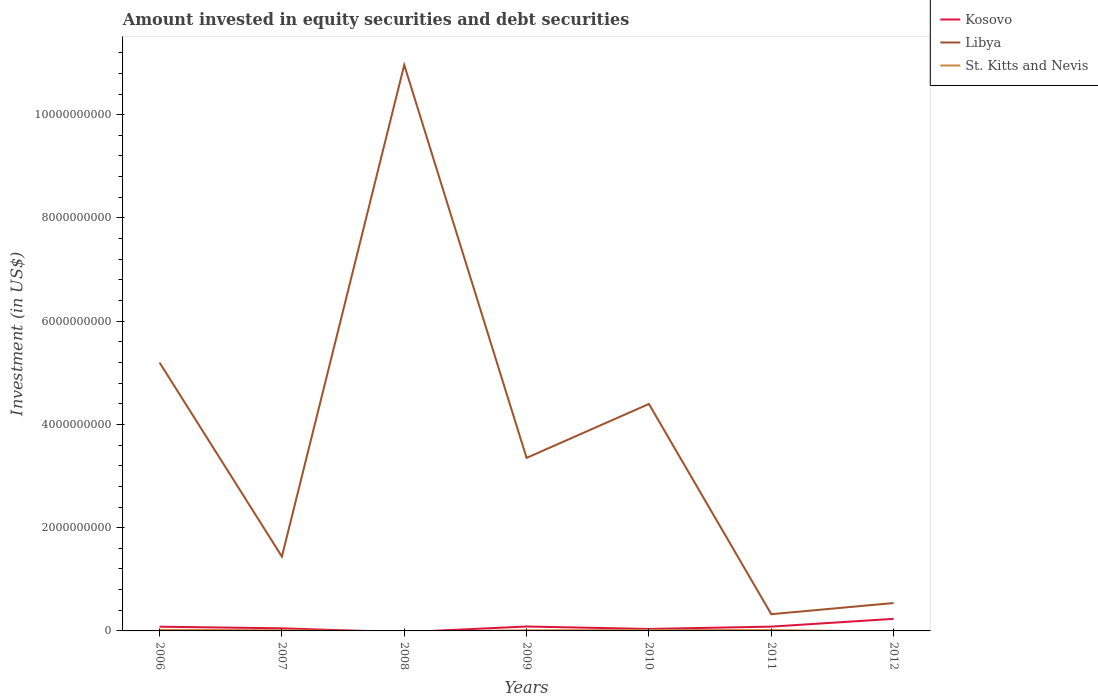How many different coloured lines are there?
Make the answer very short. 3. Is the number of lines equal to the number of legend labels?
Offer a very short reply. No. What is the total amount invested in equity securities and debt securities in Kosovo in the graph?
Keep it short and to the point. -1.15e+06. What is the difference between the highest and the second highest amount invested in equity securities and debt securities in Kosovo?
Offer a very short reply. 2.34e+08. What is the difference between the highest and the lowest amount invested in equity securities and debt securities in St. Kitts and Nevis?
Ensure brevity in your answer.  5. What is the difference between two consecutive major ticks on the Y-axis?
Offer a very short reply. 2.00e+09. Does the graph contain any zero values?
Give a very brief answer. Yes. How many legend labels are there?
Provide a short and direct response. 3. What is the title of the graph?
Make the answer very short. Amount invested in equity securities and debt securities. Does "Vietnam" appear as one of the legend labels in the graph?
Your answer should be very brief. No. What is the label or title of the Y-axis?
Offer a very short reply. Investment (in US$). What is the Investment (in US$) in Kosovo in 2006?
Make the answer very short. 8.20e+07. What is the Investment (in US$) in Libya in 2006?
Make the answer very short. 5.20e+09. What is the Investment (in US$) of St. Kitts and Nevis in 2006?
Give a very brief answer. 2.10e+07. What is the Investment (in US$) of Kosovo in 2007?
Your response must be concise. 5.01e+07. What is the Investment (in US$) in Libya in 2007?
Your answer should be very brief. 1.44e+09. What is the Investment (in US$) of St. Kitts and Nevis in 2007?
Make the answer very short. 1.30e+07. What is the Investment (in US$) of Kosovo in 2008?
Ensure brevity in your answer.  0. What is the Investment (in US$) in Libya in 2008?
Your answer should be compact. 1.10e+1. What is the Investment (in US$) in Kosovo in 2009?
Provide a succinct answer. 8.56e+07. What is the Investment (in US$) of Libya in 2009?
Your answer should be compact. 3.35e+09. What is the Investment (in US$) in St. Kitts and Nevis in 2009?
Ensure brevity in your answer.  1.12e+07. What is the Investment (in US$) of Kosovo in 2010?
Keep it short and to the point. 3.79e+07. What is the Investment (in US$) in Libya in 2010?
Make the answer very short. 4.40e+09. What is the Investment (in US$) in St. Kitts and Nevis in 2010?
Keep it short and to the point. 1.72e+07. What is the Investment (in US$) in Kosovo in 2011?
Your response must be concise. 8.32e+07. What is the Investment (in US$) in Libya in 2011?
Your response must be concise. 3.24e+08. What is the Investment (in US$) in St. Kitts and Nevis in 2011?
Keep it short and to the point. 1.55e+07. What is the Investment (in US$) in Kosovo in 2012?
Your response must be concise. 2.34e+08. What is the Investment (in US$) of Libya in 2012?
Make the answer very short. 5.40e+08. What is the Investment (in US$) in St. Kitts and Nevis in 2012?
Your answer should be very brief. 0. Across all years, what is the maximum Investment (in US$) of Kosovo?
Make the answer very short. 2.34e+08. Across all years, what is the maximum Investment (in US$) in Libya?
Your response must be concise. 1.10e+1. Across all years, what is the maximum Investment (in US$) of St. Kitts and Nevis?
Your response must be concise. 2.10e+07. Across all years, what is the minimum Investment (in US$) in Libya?
Ensure brevity in your answer.  3.24e+08. What is the total Investment (in US$) of Kosovo in the graph?
Provide a short and direct response. 5.73e+08. What is the total Investment (in US$) in Libya in the graph?
Offer a terse response. 2.62e+1. What is the total Investment (in US$) in St. Kitts and Nevis in the graph?
Give a very brief answer. 7.78e+07. What is the difference between the Investment (in US$) of Kosovo in 2006 and that in 2007?
Provide a short and direct response. 3.19e+07. What is the difference between the Investment (in US$) in Libya in 2006 and that in 2007?
Offer a very short reply. 3.76e+09. What is the difference between the Investment (in US$) of St. Kitts and Nevis in 2006 and that in 2007?
Make the answer very short. 7.99e+06. What is the difference between the Investment (in US$) in Libya in 2006 and that in 2008?
Make the answer very short. -5.77e+09. What is the difference between the Investment (in US$) in Kosovo in 2006 and that in 2009?
Your answer should be very brief. -3.60e+06. What is the difference between the Investment (in US$) of Libya in 2006 and that in 2009?
Your response must be concise. 1.85e+09. What is the difference between the Investment (in US$) of St. Kitts and Nevis in 2006 and that in 2009?
Give a very brief answer. 9.81e+06. What is the difference between the Investment (in US$) in Kosovo in 2006 and that in 2010?
Make the answer very short. 4.41e+07. What is the difference between the Investment (in US$) of Libya in 2006 and that in 2010?
Provide a succinct answer. 8.02e+08. What is the difference between the Investment (in US$) of St. Kitts and Nevis in 2006 and that in 2010?
Keep it short and to the point. 3.73e+06. What is the difference between the Investment (in US$) in Kosovo in 2006 and that in 2011?
Your answer should be compact. -1.15e+06. What is the difference between the Investment (in US$) of Libya in 2006 and that in 2011?
Make the answer very short. 4.87e+09. What is the difference between the Investment (in US$) of St. Kitts and Nevis in 2006 and that in 2011?
Provide a succinct answer. 5.51e+06. What is the difference between the Investment (in US$) in Kosovo in 2006 and that in 2012?
Your answer should be compact. -1.52e+08. What is the difference between the Investment (in US$) of Libya in 2006 and that in 2012?
Ensure brevity in your answer.  4.66e+09. What is the difference between the Investment (in US$) of Libya in 2007 and that in 2008?
Provide a succinct answer. -9.52e+09. What is the difference between the Investment (in US$) in Kosovo in 2007 and that in 2009?
Give a very brief answer. -3.55e+07. What is the difference between the Investment (in US$) of Libya in 2007 and that in 2009?
Provide a succinct answer. -1.91e+09. What is the difference between the Investment (in US$) of St. Kitts and Nevis in 2007 and that in 2009?
Offer a terse response. 1.82e+06. What is the difference between the Investment (in US$) of Kosovo in 2007 and that in 2010?
Your answer should be very brief. 1.22e+07. What is the difference between the Investment (in US$) of Libya in 2007 and that in 2010?
Keep it short and to the point. -2.96e+09. What is the difference between the Investment (in US$) in St. Kitts and Nevis in 2007 and that in 2010?
Provide a short and direct response. -4.27e+06. What is the difference between the Investment (in US$) of Kosovo in 2007 and that in 2011?
Provide a succinct answer. -3.31e+07. What is the difference between the Investment (in US$) in Libya in 2007 and that in 2011?
Keep it short and to the point. 1.12e+09. What is the difference between the Investment (in US$) in St. Kitts and Nevis in 2007 and that in 2011?
Provide a succinct answer. -2.48e+06. What is the difference between the Investment (in US$) in Kosovo in 2007 and that in 2012?
Give a very brief answer. -1.84e+08. What is the difference between the Investment (in US$) of Libya in 2007 and that in 2012?
Your response must be concise. 9.00e+08. What is the difference between the Investment (in US$) of Libya in 2008 and that in 2009?
Your answer should be compact. 7.61e+09. What is the difference between the Investment (in US$) of Libya in 2008 and that in 2010?
Ensure brevity in your answer.  6.57e+09. What is the difference between the Investment (in US$) in Libya in 2008 and that in 2011?
Your answer should be very brief. 1.06e+1. What is the difference between the Investment (in US$) of Libya in 2008 and that in 2012?
Offer a terse response. 1.04e+1. What is the difference between the Investment (in US$) in Kosovo in 2009 and that in 2010?
Offer a terse response. 4.77e+07. What is the difference between the Investment (in US$) in Libya in 2009 and that in 2010?
Provide a succinct answer. -1.04e+09. What is the difference between the Investment (in US$) of St. Kitts and Nevis in 2009 and that in 2010?
Your response must be concise. -6.08e+06. What is the difference between the Investment (in US$) in Kosovo in 2009 and that in 2011?
Your answer should be compact. 2.44e+06. What is the difference between the Investment (in US$) in Libya in 2009 and that in 2011?
Your answer should be very brief. 3.03e+09. What is the difference between the Investment (in US$) in St. Kitts and Nevis in 2009 and that in 2011?
Provide a short and direct response. -4.30e+06. What is the difference between the Investment (in US$) in Kosovo in 2009 and that in 2012?
Offer a terse response. -1.48e+08. What is the difference between the Investment (in US$) in Libya in 2009 and that in 2012?
Keep it short and to the point. 2.81e+09. What is the difference between the Investment (in US$) in Kosovo in 2010 and that in 2011?
Keep it short and to the point. -4.53e+07. What is the difference between the Investment (in US$) of Libya in 2010 and that in 2011?
Provide a succinct answer. 4.07e+09. What is the difference between the Investment (in US$) of St. Kitts and Nevis in 2010 and that in 2011?
Offer a terse response. 1.78e+06. What is the difference between the Investment (in US$) of Kosovo in 2010 and that in 2012?
Make the answer very short. -1.96e+08. What is the difference between the Investment (in US$) of Libya in 2010 and that in 2012?
Your answer should be compact. 3.86e+09. What is the difference between the Investment (in US$) of Kosovo in 2011 and that in 2012?
Your answer should be compact. -1.51e+08. What is the difference between the Investment (in US$) of Libya in 2011 and that in 2012?
Offer a terse response. -2.16e+08. What is the difference between the Investment (in US$) of Kosovo in 2006 and the Investment (in US$) of Libya in 2007?
Offer a terse response. -1.36e+09. What is the difference between the Investment (in US$) of Kosovo in 2006 and the Investment (in US$) of St. Kitts and Nevis in 2007?
Ensure brevity in your answer.  6.91e+07. What is the difference between the Investment (in US$) of Libya in 2006 and the Investment (in US$) of St. Kitts and Nevis in 2007?
Offer a very short reply. 5.19e+09. What is the difference between the Investment (in US$) in Kosovo in 2006 and the Investment (in US$) in Libya in 2008?
Offer a terse response. -1.09e+1. What is the difference between the Investment (in US$) of Kosovo in 2006 and the Investment (in US$) of Libya in 2009?
Your response must be concise. -3.27e+09. What is the difference between the Investment (in US$) of Kosovo in 2006 and the Investment (in US$) of St. Kitts and Nevis in 2009?
Ensure brevity in your answer.  7.09e+07. What is the difference between the Investment (in US$) of Libya in 2006 and the Investment (in US$) of St. Kitts and Nevis in 2009?
Your answer should be compact. 5.19e+09. What is the difference between the Investment (in US$) in Kosovo in 2006 and the Investment (in US$) in Libya in 2010?
Provide a succinct answer. -4.31e+09. What is the difference between the Investment (in US$) in Kosovo in 2006 and the Investment (in US$) in St. Kitts and Nevis in 2010?
Provide a succinct answer. 6.48e+07. What is the difference between the Investment (in US$) in Libya in 2006 and the Investment (in US$) in St. Kitts and Nevis in 2010?
Provide a short and direct response. 5.18e+09. What is the difference between the Investment (in US$) of Kosovo in 2006 and the Investment (in US$) of Libya in 2011?
Your answer should be compact. -2.42e+08. What is the difference between the Investment (in US$) of Kosovo in 2006 and the Investment (in US$) of St. Kitts and Nevis in 2011?
Keep it short and to the point. 6.66e+07. What is the difference between the Investment (in US$) of Libya in 2006 and the Investment (in US$) of St. Kitts and Nevis in 2011?
Ensure brevity in your answer.  5.18e+09. What is the difference between the Investment (in US$) in Kosovo in 2006 and the Investment (in US$) in Libya in 2012?
Offer a terse response. -4.58e+08. What is the difference between the Investment (in US$) of Kosovo in 2007 and the Investment (in US$) of Libya in 2008?
Your response must be concise. -1.09e+1. What is the difference between the Investment (in US$) in Kosovo in 2007 and the Investment (in US$) in Libya in 2009?
Your response must be concise. -3.30e+09. What is the difference between the Investment (in US$) in Kosovo in 2007 and the Investment (in US$) in St. Kitts and Nevis in 2009?
Keep it short and to the point. 3.89e+07. What is the difference between the Investment (in US$) in Libya in 2007 and the Investment (in US$) in St. Kitts and Nevis in 2009?
Offer a terse response. 1.43e+09. What is the difference between the Investment (in US$) in Kosovo in 2007 and the Investment (in US$) in Libya in 2010?
Provide a short and direct response. -4.35e+09. What is the difference between the Investment (in US$) in Kosovo in 2007 and the Investment (in US$) in St. Kitts and Nevis in 2010?
Offer a terse response. 3.29e+07. What is the difference between the Investment (in US$) in Libya in 2007 and the Investment (in US$) in St. Kitts and Nevis in 2010?
Provide a succinct answer. 1.42e+09. What is the difference between the Investment (in US$) of Kosovo in 2007 and the Investment (in US$) of Libya in 2011?
Your answer should be very brief. -2.74e+08. What is the difference between the Investment (in US$) of Kosovo in 2007 and the Investment (in US$) of St. Kitts and Nevis in 2011?
Your answer should be very brief. 3.46e+07. What is the difference between the Investment (in US$) of Libya in 2007 and the Investment (in US$) of St. Kitts and Nevis in 2011?
Provide a short and direct response. 1.42e+09. What is the difference between the Investment (in US$) in Kosovo in 2007 and the Investment (in US$) in Libya in 2012?
Keep it short and to the point. -4.90e+08. What is the difference between the Investment (in US$) in Libya in 2008 and the Investment (in US$) in St. Kitts and Nevis in 2009?
Offer a very short reply. 1.10e+1. What is the difference between the Investment (in US$) in Libya in 2008 and the Investment (in US$) in St. Kitts and Nevis in 2010?
Provide a succinct answer. 1.09e+1. What is the difference between the Investment (in US$) of Libya in 2008 and the Investment (in US$) of St. Kitts and Nevis in 2011?
Keep it short and to the point. 1.09e+1. What is the difference between the Investment (in US$) of Kosovo in 2009 and the Investment (in US$) of Libya in 2010?
Offer a terse response. -4.31e+09. What is the difference between the Investment (in US$) in Kosovo in 2009 and the Investment (in US$) in St. Kitts and Nevis in 2010?
Keep it short and to the point. 6.84e+07. What is the difference between the Investment (in US$) of Libya in 2009 and the Investment (in US$) of St. Kitts and Nevis in 2010?
Offer a terse response. 3.33e+09. What is the difference between the Investment (in US$) in Kosovo in 2009 and the Investment (in US$) in Libya in 2011?
Your response must be concise. -2.38e+08. What is the difference between the Investment (in US$) in Kosovo in 2009 and the Investment (in US$) in St. Kitts and Nevis in 2011?
Provide a succinct answer. 7.02e+07. What is the difference between the Investment (in US$) of Libya in 2009 and the Investment (in US$) of St. Kitts and Nevis in 2011?
Your response must be concise. 3.34e+09. What is the difference between the Investment (in US$) of Kosovo in 2009 and the Investment (in US$) of Libya in 2012?
Your answer should be very brief. -4.55e+08. What is the difference between the Investment (in US$) in Kosovo in 2010 and the Investment (in US$) in Libya in 2011?
Provide a succinct answer. -2.86e+08. What is the difference between the Investment (in US$) in Kosovo in 2010 and the Investment (in US$) in St. Kitts and Nevis in 2011?
Give a very brief answer. 2.24e+07. What is the difference between the Investment (in US$) of Libya in 2010 and the Investment (in US$) of St. Kitts and Nevis in 2011?
Your response must be concise. 4.38e+09. What is the difference between the Investment (in US$) in Kosovo in 2010 and the Investment (in US$) in Libya in 2012?
Provide a succinct answer. -5.02e+08. What is the difference between the Investment (in US$) in Kosovo in 2011 and the Investment (in US$) in Libya in 2012?
Your answer should be very brief. -4.57e+08. What is the average Investment (in US$) of Kosovo per year?
Your answer should be compact. 8.18e+07. What is the average Investment (in US$) of Libya per year?
Make the answer very short. 3.74e+09. What is the average Investment (in US$) in St. Kitts and Nevis per year?
Your response must be concise. 1.11e+07. In the year 2006, what is the difference between the Investment (in US$) in Kosovo and Investment (in US$) in Libya?
Provide a succinct answer. -5.12e+09. In the year 2006, what is the difference between the Investment (in US$) of Kosovo and Investment (in US$) of St. Kitts and Nevis?
Offer a terse response. 6.11e+07. In the year 2006, what is the difference between the Investment (in US$) in Libya and Investment (in US$) in St. Kitts and Nevis?
Keep it short and to the point. 5.18e+09. In the year 2007, what is the difference between the Investment (in US$) of Kosovo and Investment (in US$) of Libya?
Provide a succinct answer. -1.39e+09. In the year 2007, what is the difference between the Investment (in US$) of Kosovo and Investment (in US$) of St. Kitts and Nevis?
Offer a very short reply. 3.71e+07. In the year 2007, what is the difference between the Investment (in US$) in Libya and Investment (in US$) in St. Kitts and Nevis?
Ensure brevity in your answer.  1.43e+09. In the year 2009, what is the difference between the Investment (in US$) in Kosovo and Investment (in US$) in Libya?
Offer a terse response. -3.27e+09. In the year 2009, what is the difference between the Investment (in US$) of Kosovo and Investment (in US$) of St. Kitts and Nevis?
Ensure brevity in your answer.  7.45e+07. In the year 2009, what is the difference between the Investment (in US$) in Libya and Investment (in US$) in St. Kitts and Nevis?
Your response must be concise. 3.34e+09. In the year 2010, what is the difference between the Investment (in US$) of Kosovo and Investment (in US$) of Libya?
Provide a succinct answer. -4.36e+09. In the year 2010, what is the difference between the Investment (in US$) in Kosovo and Investment (in US$) in St. Kitts and Nevis?
Your answer should be compact. 2.07e+07. In the year 2010, what is the difference between the Investment (in US$) of Libya and Investment (in US$) of St. Kitts and Nevis?
Offer a very short reply. 4.38e+09. In the year 2011, what is the difference between the Investment (in US$) in Kosovo and Investment (in US$) in Libya?
Give a very brief answer. -2.41e+08. In the year 2011, what is the difference between the Investment (in US$) in Kosovo and Investment (in US$) in St. Kitts and Nevis?
Your answer should be compact. 6.77e+07. In the year 2011, what is the difference between the Investment (in US$) of Libya and Investment (in US$) of St. Kitts and Nevis?
Provide a succinct answer. 3.09e+08. In the year 2012, what is the difference between the Investment (in US$) in Kosovo and Investment (in US$) in Libya?
Your answer should be very brief. -3.06e+08. What is the ratio of the Investment (in US$) in Kosovo in 2006 to that in 2007?
Make the answer very short. 1.64. What is the ratio of the Investment (in US$) of Libya in 2006 to that in 2007?
Offer a terse response. 3.61. What is the ratio of the Investment (in US$) in St. Kitts and Nevis in 2006 to that in 2007?
Your response must be concise. 1.62. What is the ratio of the Investment (in US$) of Libya in 2006 to that in 2008?
Your response must be concise. 0.47. What is the ratio of the Investment (in US$) of Kosovo in 2006 to that in 2009?
Give a very brief answer. 0.96. What is the ratio of the Investment (in US$) in Libya in 2006 to that in 2009?
Keep it short and to the point. 1.55. What is the ratio of the Investment (in US$) of St. Kitts and Nevis in 2006 to that in 2009?
Give a very brief answer. 1.88. What is the ratio of the Investment (in US$) in Kosovo in 2006 to that in 2010?
Your response must be concise. 2.16. What is the ratio of the Investment (in US$) of Libya in 2006 to that in 2010?
Provide a succinct answer. 1.18. What is the ratio of the Investment (in US$) in St. Kitts and Nevis in 2006 to that in 2010?
Your answer should be very brief. 1.22. What is the ratio of the Investment (in US$) in Kosovo in 2006 to that in 2011?
Your answer should be very brief. 0.99. What is the ratio of the Investment (in US$) of Libya in 2006 to that in 2011?
Give a very brief answer. 16.04. What is the ratio of the Investment (in US$) of St. Kitts and Nevis in 2006 to that in 2011?
Provide a succinct answer. 1.36. What is the ratio of the Investment (in US$) of Kosovo in 2006 to that in 2012?
Your response must be concise. 0.35. What is the ratio of the Investment (in US$) of Libya in 2006 to that in 2012?
Your response must be concise. 9.62. What is the ratio of the Investment (in US$) of Libya in 2007 to that in 2008?
Provide a short and direct response. 0.13. What is the ratio of the Investment (in US$) in Kosovo in 2007 to that in 2009?
Your answer should be compact. 0.59. What is the ratio of the Investment (in US$) of Libya in 2007 to that in 2009?
Your response must be concise. 0.43. What is the ratio of the Investment (in US$) of St. Kitts and Nevis in 2007 to that in 2009?
Provide a succinct answer. 1.16. What is the ratio of the Investment (in US$) of Kosovo in 2007 to that in 2010?
Give a very brief answer. 1.32. What is the ratio of the Investment (in US$) in Libya in 2007 to that in 2010?
Your answer should be compact. 0.33. What is the ratio of the Investment (in US$) in St. Kitts and Nevis in 2007 to that in 2010?
Provide a succinct answer. 0.75. What is the ratio of the Investment (in US$) of Kosovo in 2007 to that in 2011?
Give a very brief answer. 0.6. What is the ratio of the Investment (in US$) of Libya in 2007 to that in 2011?
Provide a short and direct response. 4.44. What is the ratio of the Investment (in US$) of St. Kitts and Nevis in 2007 to that in 2011?
Your answer should be compact. 0.84. What is the ratio of the Investment (in US$) in Kosovo in 2007 to that in 2012?
Offer a very short reply. 0.21. What is the ratio of the Investment (in US$) in Libya in 2007 to that in 2012?
Provide a short and direct response. 2.67. What is the ratio of the Investment (in US$) in Libya in 2008 to that in 2009?
Provide a succinct answer. 3.27. What is the ratio of the Investment (in US$) of Libya in 2008 to that in 2010?
Make the answer very short. 2.49. What is the ratio of the Investment (in US$) of Libya in 2008 to that in 2011?
Make the answer very short. 33.83. What is the ratio of the Investment (in US$) in Libya in 2008 to that in 2012?
Offer a terse response. 20.29. What is the ratio of the Investment (in US$) of Kosovo in 2009 to that in 2010?
Keep it short and to the point. 2.26. What is the ratio of the Investment (in US$) of Libya in 2009 to that in 2010?
Your answer should be compact. 0.76. What is the ratio of the Investment (in US$) in St. Kitts and Nevis in 2009 to that in 2010?
Keep it short and to the point. 0.65. What is the ratio of the Investment (in US$) of Kosovo in 2009 to that in 2011?
Provide a succinct answer. 1.03. What is the ratio of the Investment (in US$) of Libya in 2009 to that in 2011?
Make the answer very short. 10.34. What is the ratio of the Investment (in US$) of St. Kitts and Nevis in 2009 to that in 2011?
Offer a terse response. 0.72. What is the ratio of the Investment (in US$) in Kosovo in 2009 to that in 2012?
Give a very brief answer. 0.37. What is the ratio of the Investment (in US$) of Libya in 2009 to that in 2012?
Keep it short and to the point. 6.2. What is the ratio of the Investment (in US$) of Kosovo in 2010 to that in 2011?
Offer a terse response. 0.46. What is the ratio of the Investment (in US$) of Libya in 2010 to that in 2011?
Your answer should be compact. 13.56. What is the ratio of the Investment (in US$) of St. Kitts and Nevis in 2010 to that in 2011?
Offer a very short reply. 1.12. What is the ratio of the Investment (in US$) in Kosovo in 2010 to that in 2012?
Ensure brevity in your answer.  0.16. What is the ratio of the Investment (in US$) in Libya in 2010 to that in 2012?
Ensure brevity in your answer.  8.14. What is the ratio of the Investment (in US$) of Kosovo in 2011 to that in 2012?
Keep it short and to the point. 0.36. What is the ratio of the Investment (in US$) of Libya in 2011 to that in 2012?
Keep it short and to the point. 0.6. What is the difference between the highest and the second highest Investment (in US$) in Kosovo?
Your answer should be compact. 1.48e+08. What is the difference between the highest and the second highest Investment (in US$) in Libya?
Ensure brevity in your answer.  5.77e+09. What is the difference between the highest and the second highest Investment (in US$) in St. Kitts and Nevis?
Your answer should be compact. 3.73e+06. What is the difference between the highest and the lowest Investment (in US$) in Kosovo?
Your answer should be very brief. 2.34e+08. What is the difference between the highest and the lowest Investment (in US$) of Libya?
Provide a succinct answer. 1.06e+1. What is the difference between the highest and the lowest Investment (in US$) in St. Kitts and Nevis?
Give a very brief answer. 2.10e+07. 